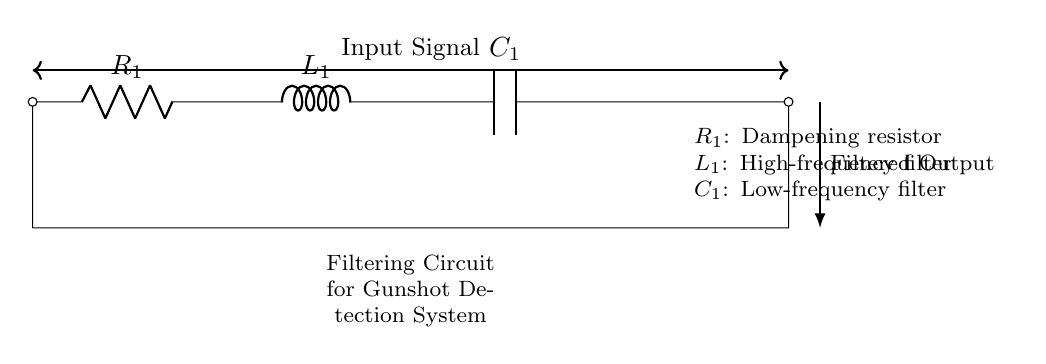What is the type of filtering circuit shown? The circuit is a Resistor-Inductor-Capacitor (RLC) circuit that filters signals for accuracy in gunshot detection systems.
Answer: RLC What does R1 represent in the circuit? R1 is labeled as a dampening resistor, which helps to reduce the amplitude of high-frequency signals.
Answer: Dampening resistor What type of filter does L1 act as in this circuit? L1 is a high-frequency filter that allows low-frequency signals to pass while attenuating high-frequency noise.
Answer: High-frequency filter What is the role of C1 in this circuit? C1 functions as a low-frequency filter, blocking low-frequency signals and allowing high-frequency signals to pass.
Answer: Low-frequency filter How many components are there in the circuit? Counting R1, L1, and C1, there are three components in the circuit diagram.
Answer: Three Why is filtering important in gunshot detection systems? Filtering is essential to improve the accuracy of detecting gunshot noise while minimizing false positives from other sounds.
Answer: Improve accuracy What is the output of the circuit labeled as? The output of the circuit is labeled as "Filtered Output," indicating that it delivers a cleaner signal after filtering.
Answer: Filtered Output 